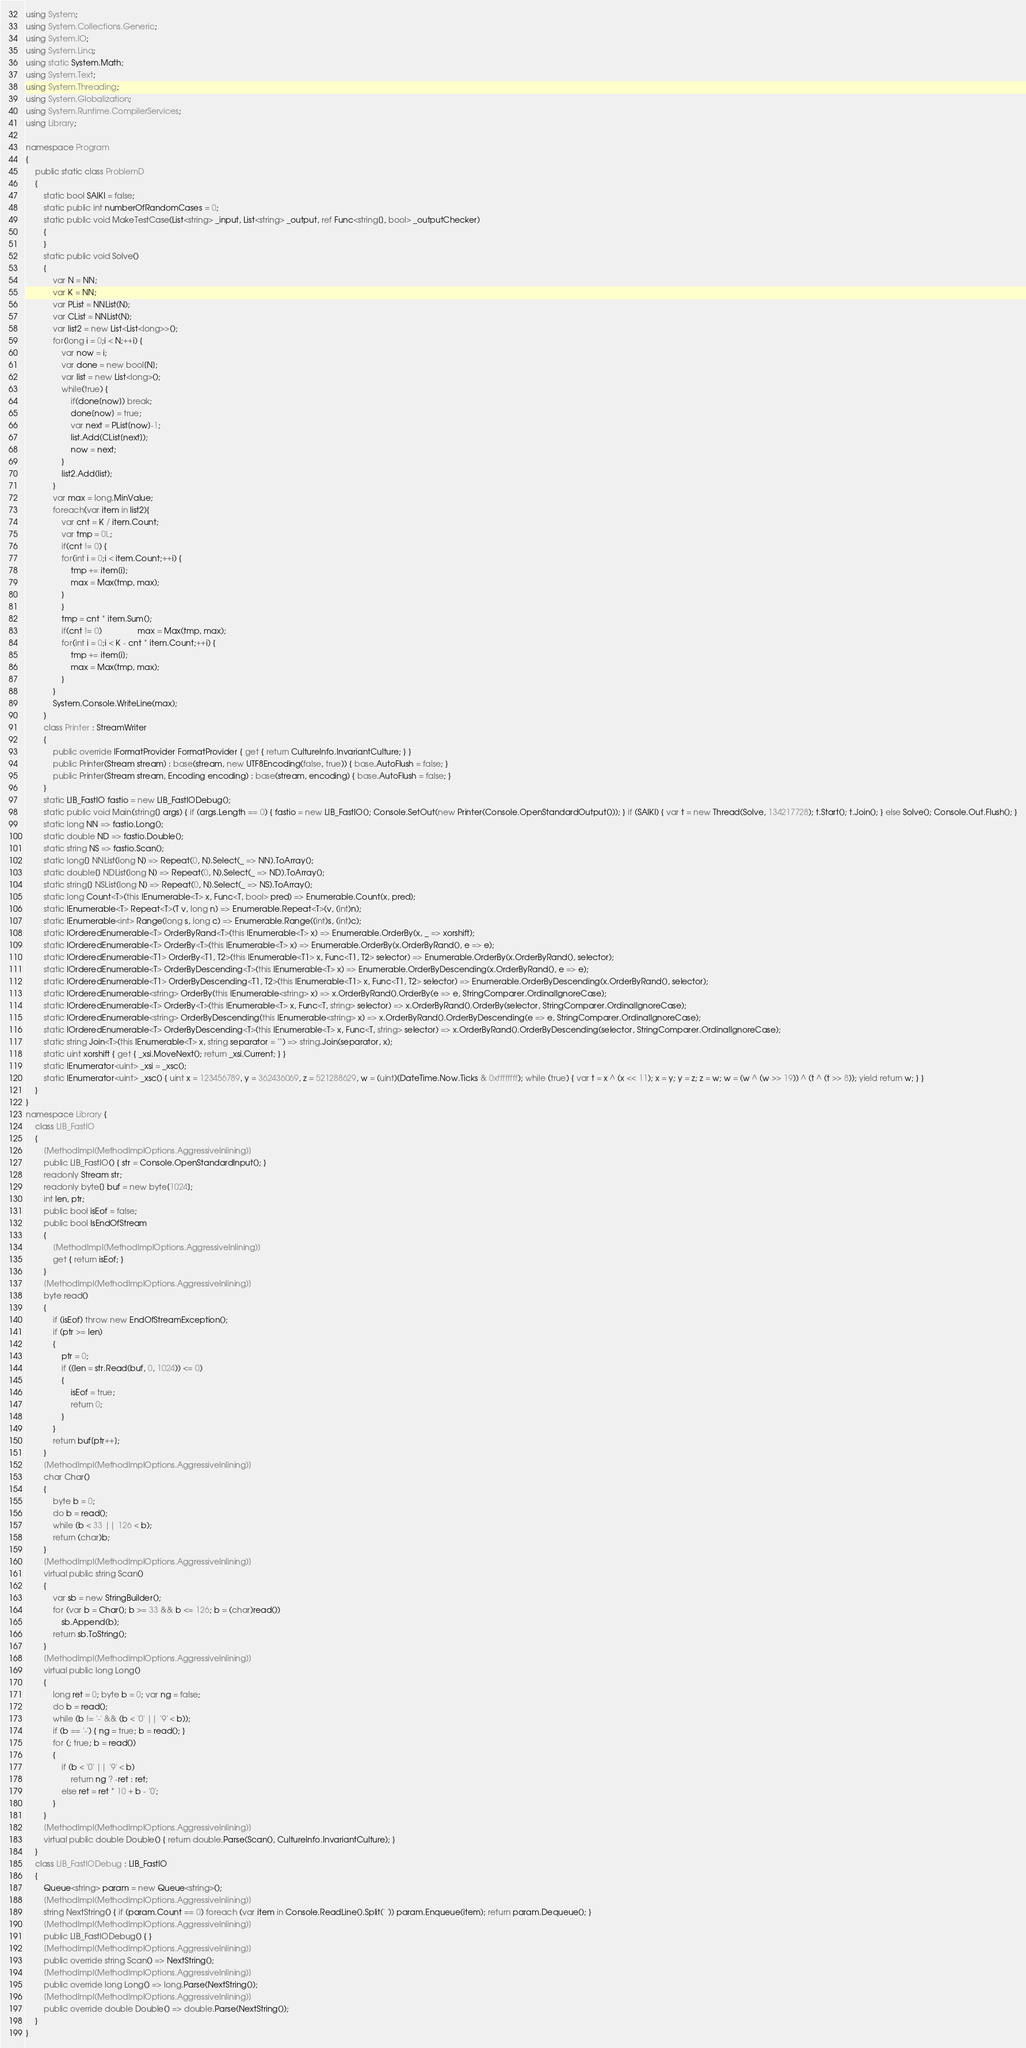Convert code to text. <code><loc_0><loc_0><loc_500><loc_500><_C#_>using System;
using System.Collections.Generic;
using System.IO;
using System.Linq;
using static System.Math;
using System.Text;
using System.Threading;
using System.Globalization;
using System.Runtime.CompilerServices;
using Library;

namespace Program
{
    public static class ProblemD
    {
        static bool SAIKI = false;
        static public int numberOfRandomCases = 0;
        static public void MakeTestCase(List<string> _input, List<string> _output, ref Func<string[], bool> _outputChecker)
        {
        }
        static public void Solve()
        {
            var N = NN;
            var K = NN;
            var PList = NNList(N);
            var CList = NNList(N);
            var list2 = new List<List<long>>();
            for(long i = 0;i < N;++i) {
                var now = i;
                var done = new bool[N];
                var list = new List<long>();
                while(true) {
                    if(done[now]) break;
                    done[now] = true;
                    var next = PList[now]-1;
                    list.Add(CList[next]);
                    now = next;
                }
                list2.Add(list);
            }
            var max = long.MinValue;
            foreach(var item in list2){
                var cnt = K / item.Count;
                var tmp = 0L;
                if(cnt != 0) {
                for(int i = 0;i < item.Count;++i) {
                    tmp += item[i];
                    max = Max(tmp, max);
                }
                }
                tmp = cnt * item.Sum();
                if(cnt != 0)                max = Max(tmp, max);
                for(int i = 0;i < K - cnt * item.Count;++i) {
                    tmp += item[i];
                    max = Max(tmp, max);
                }
            }
            System.Console.WriteLine(max);
        }
        class Printer : StreamWriter
        {
            public override IFormatProvider FormatProvider { get { return CultureInfo.InvariantCulture; } }
            public Printer(Stream stream) : base(stream, new UTF8Encoding(false, true)) { base.AutoFlush = false; }
            public Printer(Stream stream, Encoding encoding) : base(stream, encoding) { base.AutoFlush = false; }
        }
        static LIB_FastIO fastio = new LIB_FastIODebug();
        static public void Main(string[] args) { if (args.Length == 0) { fastio = new LIB_FastIO(); Console.SetOut(new Printer(Console.OpenStandardOutput())); } if (SAIKI) { var t = new Thread(Solve, 134217728); t.Start(); t.Join(); } else Solve(); Console.Out.Flush(); }
        static long NN => fastio.Long();
        static double ND => fastio.Double();
        static string NS => fastio.Scan();
        static long[] NNList(long N) => Repeat(0, N).Select(_ => NN).ToArray();
        static double[] NDList(long N) => Repeat(0, N).Select(_ => ND).ToArray();
        static string[] NSList(long N) => Repeat(0, N).Select(_ => NS).ToArray();
        static long Count<T>(this IEnumerable<T> x, Func<T, bool> pred) => Enumerable.Count(x, pred);
        static IEnumerable<T> Repeat<T>(T v, long n) => Enumerable.Repeat<T>(v, (int)n);
        static IEnumerable<int> Range(long s, long c) => Enumerable.Range((int)s, (int)c);
        static IOrderedEnumerable<T> OrderByRand<T>(this IEnumerable<T> x) => Enumerable.OrderBy(x, _ => xorshift);
        static IOrderedEnumerable<T> OrderBy<T>(this IEnumerable<T> x) => Enumerable.OrderBy(x.OrderByRand(), e => e);
        static IOrderedEnumerable<T1> OrderBy<T1, T2>(this IEnumerable<T1> x, Func<T1, T2> selector) => Enumerable.OrderBy(x.OrderByRand(), selector);
        static IOrderedEnumerable<T> OrderByDescending<T>(this IEnumerable<T> x) => Enumerable.OrderByDescending(x.OrderByRand(), e => e);
        static IOrderedEnumerable<T1> OrderByDescending<T1, T2>(this IEnumerable<T1> x, Func<T1, T2> selector) => Enumerable.OrderByDescending(x.OrderByRand(), selector);
        static IOrderedEnumerable<string> OrderBy(this IEnumerable<string> x) => x.OrderByRand().OrderBy(e => e, StringComparer.OrdinalIgnoreCase);
        static IOrderedEnumerable<T> OrderBy<T>(this IEnumerable<T> x, Func<T, string> selector) => x.OrderByRand().OrderBy(selector, StringComparer.OrdinalIgnoreCase);
        static IOrderedEnumerable<string> OrderByDescending(this IEnumerable<string> x) => x.OrderByRand().OrderByDescending(e => e, StringComparer.OrdinalIgnoreCase);
        static IOrderedEnumerable<T> OrderByDescending<T>(this IEnumerable<T> x, Func<T, string> selector) => x.OrderByRand().OrderByDescending(selector, StringComparer.OrdinalIgnoreCase);
        static string Join<T>(this IEnumerable<T> x, string separator = "") => string.Join(separator, x);
        static uint xorshift { get { _xsi.MoveNext(); return _xsi.Current; } }
        static IEnumerator<uint> _xsi = _xsc();
        static IEnumerator<uint> _xsc() { uint x = 123456789, y = 362436069, z = 521288629, w = (uint)(DateTime.Now.Ticks & 0xffffffff); while (true) { var t = x ^ (x << 11); x = y; y = z; z = w; w = (w ^ (w >> 19)) ^ (t ^ (t >> 8)); yield return w; } }
    }
}
namespace Library {
    class LIB_FastIO
    {
        [MethodImpl(MethodImplOptions.AggressiveInlining)]
        public LIB_FastIO() { str = Console.OpenStandardInput(); }
        readonly Stream str;
        readonly byte[] buf = new byte[1024];
        int len, ptr;
        public bool isEof = false;
        public bool IsEndOfStream
        {
            [MethodImpl(MethodImplOptions.AggressiveInlining)]
            get { return isEof; }
        }
        [MethodImpl(MethodImplOptions.AggressiveInlining)]
        byte read()
        {
            if (isEof) throw new EndOfStreamException();
            if (ptr >= len)
            {
                ptr = 0;
                if ((len = str.Read(buf, 0, 1024)) <= 0)
                {
                    isEof = true;
                    return 0;
                }
            }
            return buf[ptr++];
        }
        [MethodImpl(MethodImplOptions.AggressiveInlining)]
        char Char()
        {
            byte b = 0;
            do b = read();
            while (b < 33 || 126 < b);
            return (char)b;
        }
        [MethodImpl(MethodImplOptions.AggressiveInlining)]
        virtual public string Scan()
        {
            var sb = new StringBuilder();
            for (var b = Char(); b >= 33 && b <= 126; b = (char)read())
                sb.Append(b);
            return sb.ToString();
        }
        [MethodImpl(MethodImplOptions.AggressiveInlining)]
        virtual public long Long()
        {
            long ret = 0; byte b = 0; var ng = false;
            do b = read();
            while (b != '-' && (b < '0' || '9' < b));
            if (b == '-') { ng = true; b = read(); }
            for (; true; b = read())
            {
                if (b < '0' || '9' < b)
                    return ng ? -ret : ret;
                else ret = ret * 10 + b - '0';
            }
        }
        [MethodImpl(MethodImplOptions.AggressiveInlining)]
        virtual public double Double() { return double.Parse(Scan(), CultureInfo.InvariantCulture); }
    }
    class LIB_FastIODebug : LIB_FastIO
    {
        Queue<string> param = new Queue<string>();
        [MethodImpl(MethodImplOptions.AggressiveInlining)]
        string NextString() { if (param.Count == 0) foreach (var item in Console.ReadLine().Split(' ')) param.Enqueue(item); return param.Dequeue(); }
        [MethodImpl(MethodImplOptions.AggressiveInlining)]
        public LIB_FastIODebug() { }
        [MethodImpl(MethodImplOptions.AggressiveInlining)]
        public override string Scan() => NextString();
        [MethodImpl(MethodImplOptions.AggressiveInlining)]
        public override long Long() => long.Parse(NextString());
        [MethodImpl(MethodImplOptions.AggressiveInlining)]
        public override double Double() => double.Parse(NextString());
    }
}
</code> 